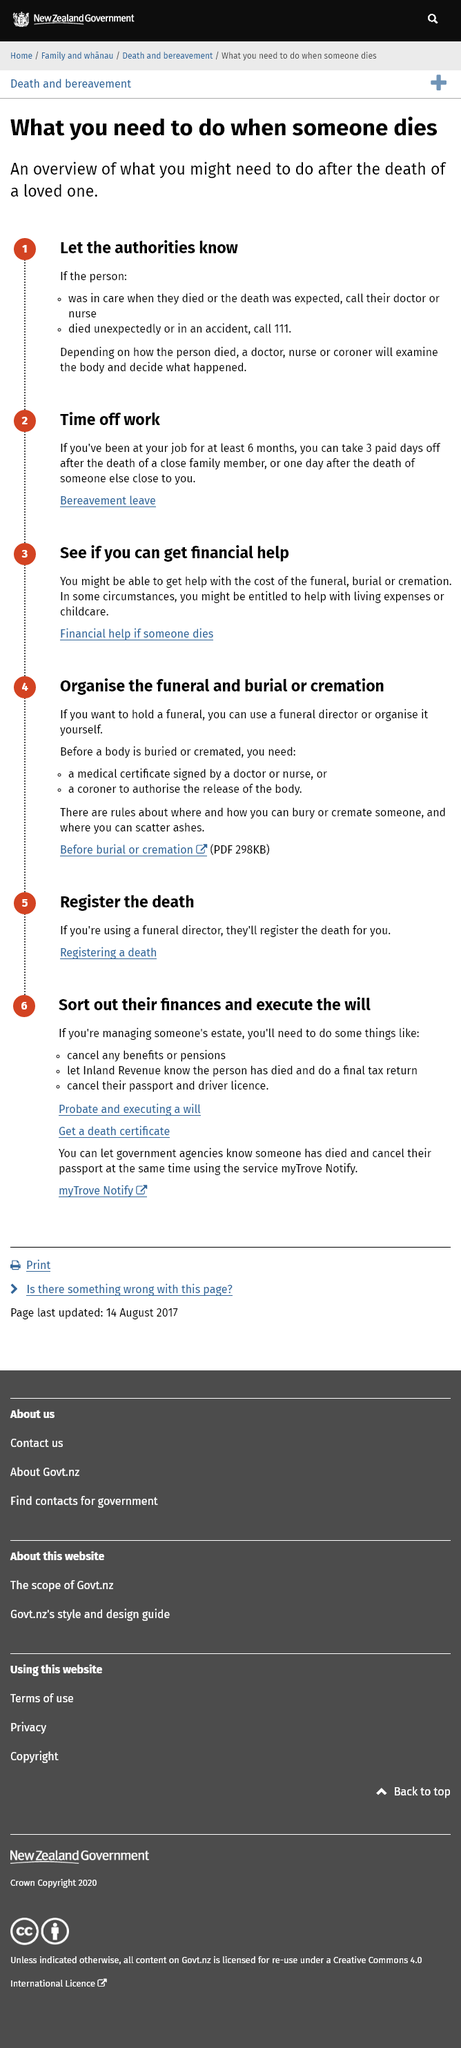Give some essential details in this illustration. If a loved one dies in an accident, it is recommended to call the emergency number, which is 111. If death was expected, it is recommended to contact a doctor or nurse. The examination of the body and determination of the cause of death is done by a doctor, nurse, or coroner, depending on the circumstances of the person's death. 